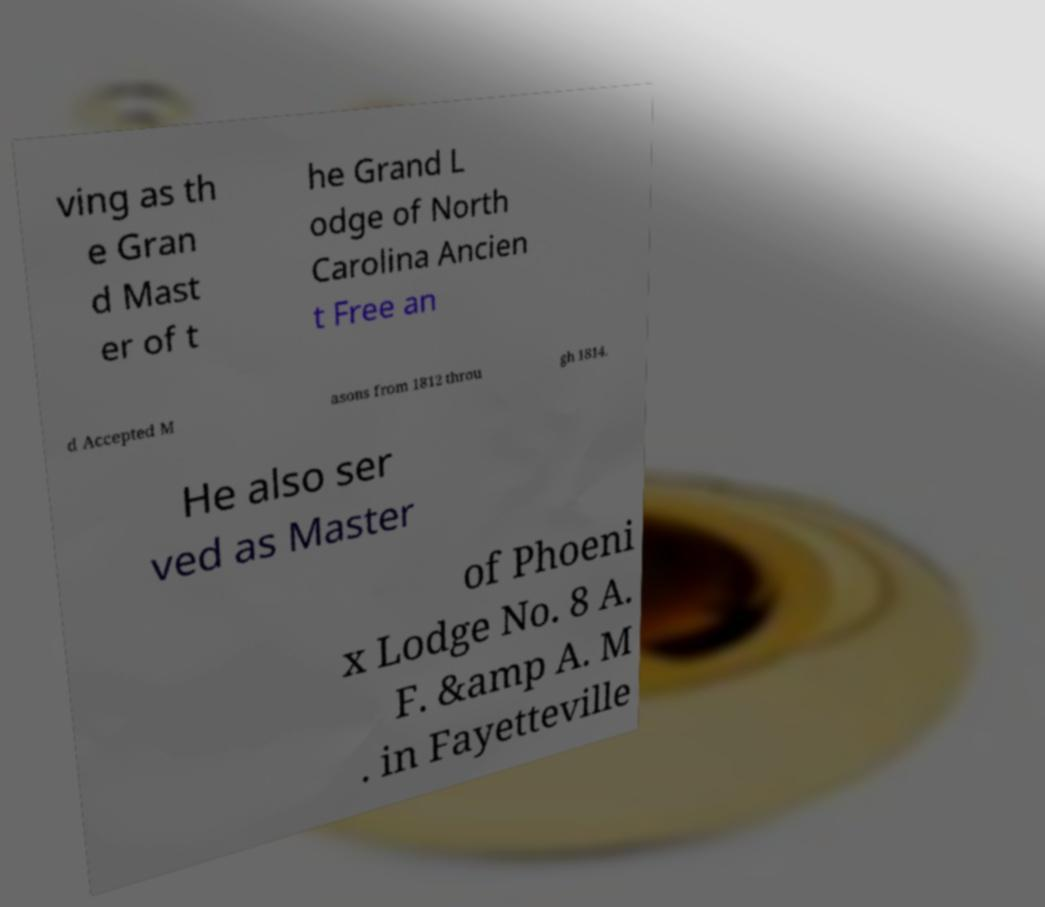Can you accurately transcribe the text from the provided image for me? ving as th e Gran d Mast er of t he Grand L odge of North Carolina Ancien t Free an d Accepted M asons from 1812 throu gh 1814. He also ser ved as Master of Phoeni x Lodge No. 8 A. F. &amp A. M . in Fayetteville 